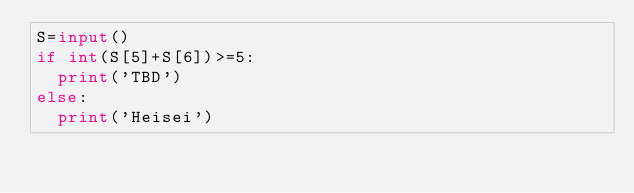<code> <loc_0><loc_0><loc_500><loc_500><_Python_>S=input()
if int(S[5]+S[6])>=5:
  print('TBD')
else:
  print('Heisei')</code> 